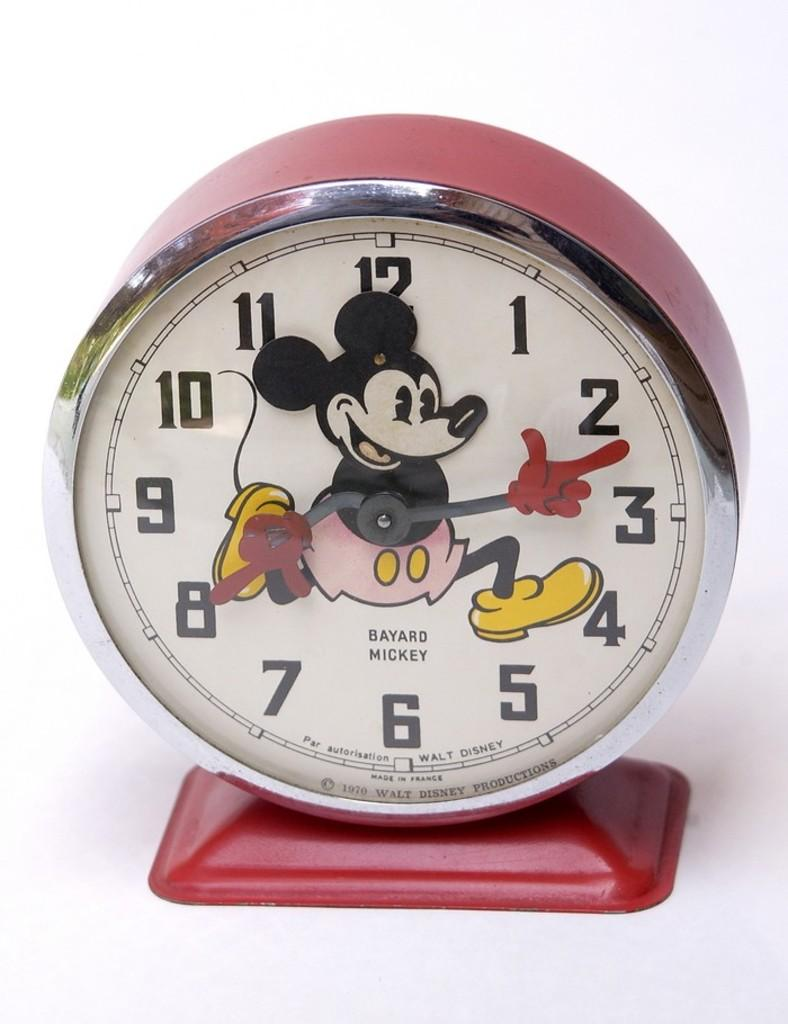<image>
Relay a brief, clear account of the picture shown. A Mickey Mouse clock that was made in France 